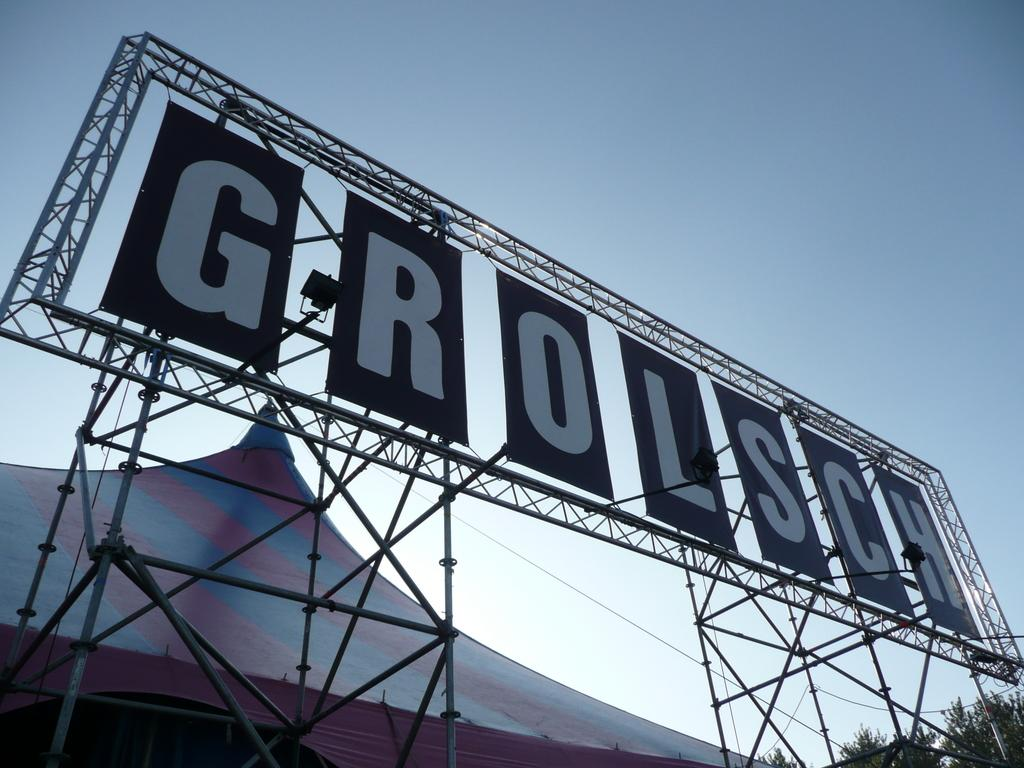Provide a one-sentence caption for the provided image. the word Grolsch is on a large sign. 